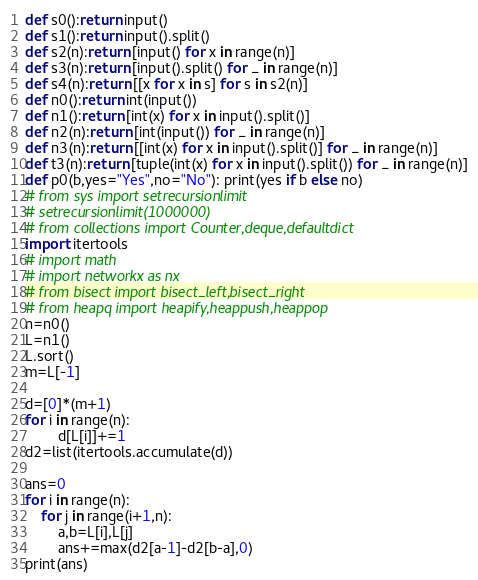Convert code to text. <code><loc_0><loc_0><loc_500><loc_500><_Python_>
def s0():return input()
def s1():return input().split()
def s2(n):return [input() for x in range(n)]
def s3(n):return [input().split() for _ in range(n)]
def s4(n):return [[x for x in s] for s in s2(n)]
def n0():return int(input())
def n1():return [int(x) for x in input().split()]
def n2(n):return [int(input()) for _ in range(n)]
def n3(n):return [[int(x) for x in input().split()] for _ in range(n)]
def t3(n):return [tuple(int(x) for x in input().split()) for _ in range(n)]
def p0(b,yes="Yes",no="No"): print(yes if b else no)
# from sys import setrecursionlimit
# setrecursionlimit(1000000)
# from collections import Counter,deque,defaultdict
import itertools
# import math
# import networkx as nx
# from bisect import bisect_left,bisect_right
# from heapq import heapify,heappush,heappop
n=n0()
L=n1()
L.sort()
m=L[-1]

d=[0]*(m+1) 
for i in range(n):
        d[L[i]]+=1
d2=list(itertools.accumulate(d))

ans=0
for i in range(n):
    for j in range(i+1,n):
        a,b=L[i],L[j]
        ans+=max(d2[a-1]-d2[b-a],0)
print(ans)</code> 